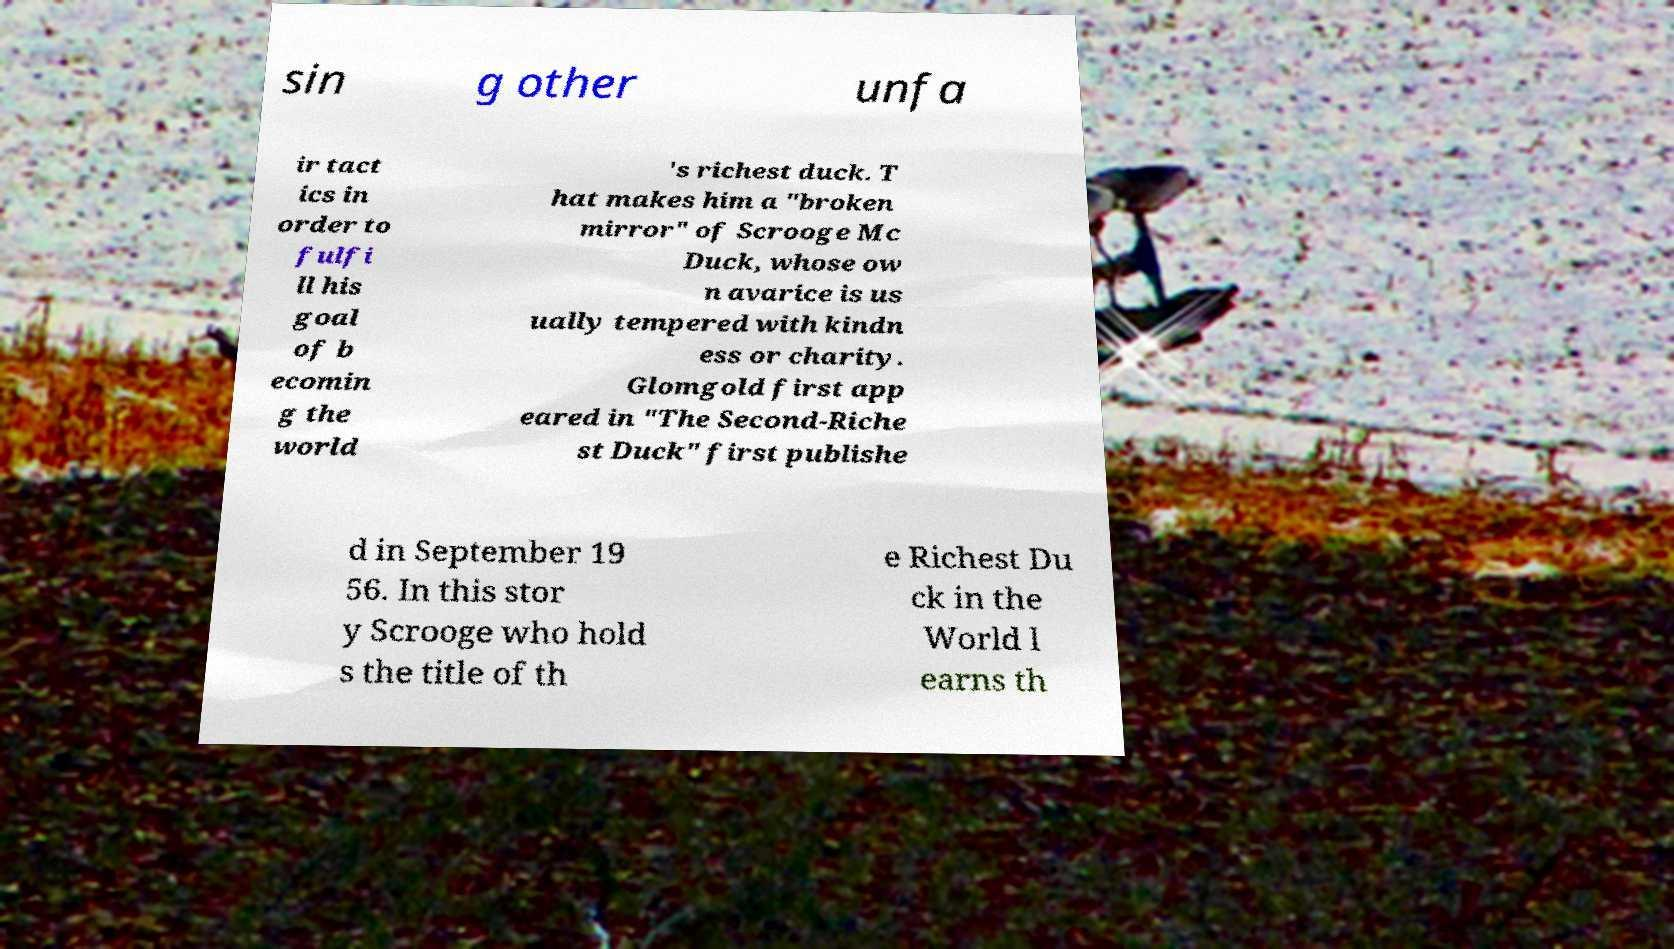I need the written content from this picture converted into text. Can you do that? sin g other unfa ir tact ics in order to fulfi ll his goal of b ecomin g the world 's richest duck. T hat makes him a "broken mirror" of Scrooge Mc Duck, whose ow n avarice is us ually tempered with kindn ess or charity. Glomgold first app eared in "The Second-Riche st Duck" first publishe d in September 19 56. In this stor y Scrooge who hold s the title of th e Richest Du ck in the World l earns th 